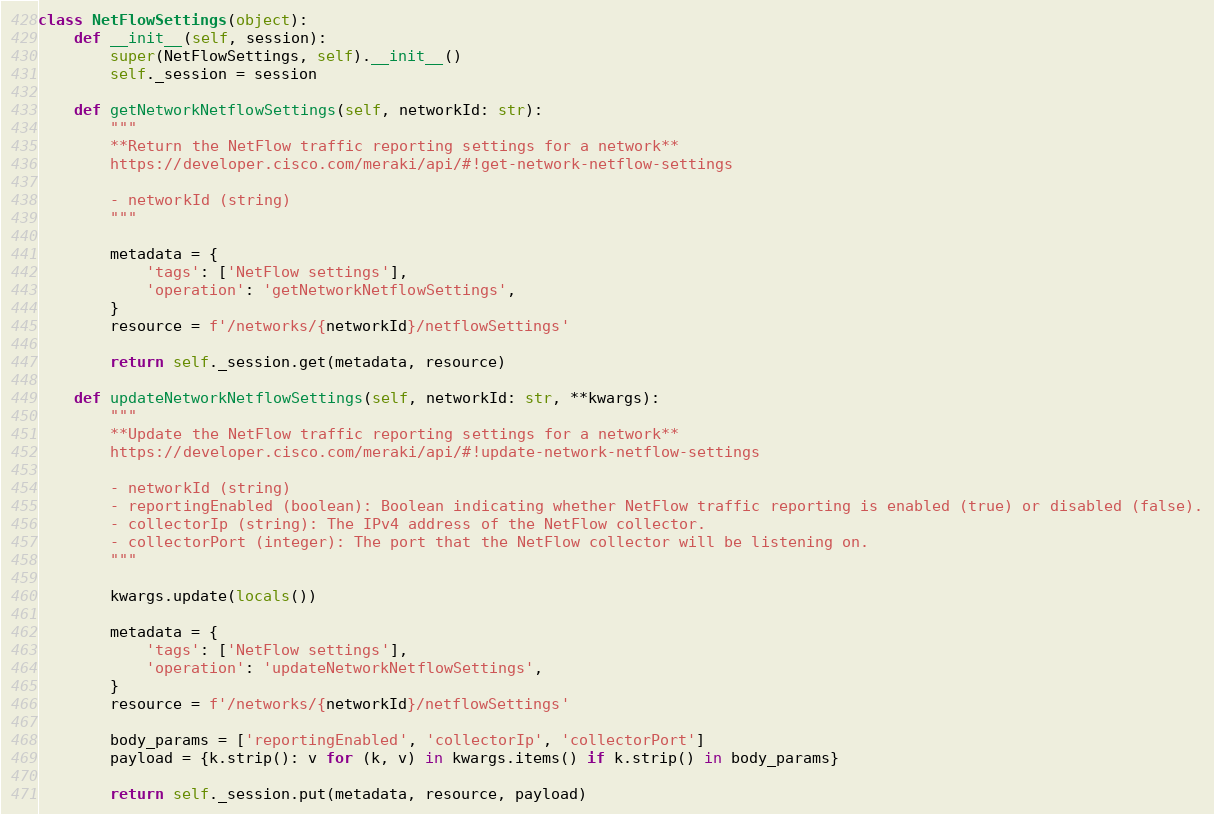Convert code to text. <code><loc_0><loc_0><loc_500><loc_500><_Python_>class NetFlowSettings(object):
    def __init__(self, session):
        super(NetFlowSettings, self).__init__()
        self._session = session
    
    def getNetworkNetflowSettings(self, networkId: str):
        """
        **Return the NetFlow traffic reporting settings for a network**
        https://developer.cisco.com/meraki/api/#!get-network-netflow-settings
        
        - networkId (string)
        """

        metadata = {
            'tags': ['NetFlow settings'],
            'operation': 'getNetworkNetflowSettings',
        }
        resource = f'/networks/{networkId}/netflowSettings'

        return self._session.get(metadata, resource)

    def updateNetworkNetflowSettings(self, networkId: str, **kwargs):
        """
        **Update the NetFlow traffic reporting settings for a network**
        https://developer.cisco.com/meraki/api/#!update-network-netflow-settings
        
        - networkId (string)
        - reportingEnabled (boolean): Boolean indicating whether NetFlow traffic reporting is enabled (true) or disabled (false).
        - collectorIp (string): The IPv4 address of the NetFlow collector.
        - collectorPort (integer): The port that the NetFlow collector will be listening on.
        """

        kwargs.update(locals())

        metadata = {
            'tags': ['NetFlow settings'],
            'operation': 'updateNetworkNetflowSettings',
        }
        resource = f'/networks/{networkId}/netflowSettings'

        body_params = ['reportingEnabled', 'collectorIp', 'collectorPort']
        payload = {k.strip(): v for (k, v) in kwargs.items() if k.strip() in body_params}

        return self._session.put(metadata, resource, payload)

</code> 